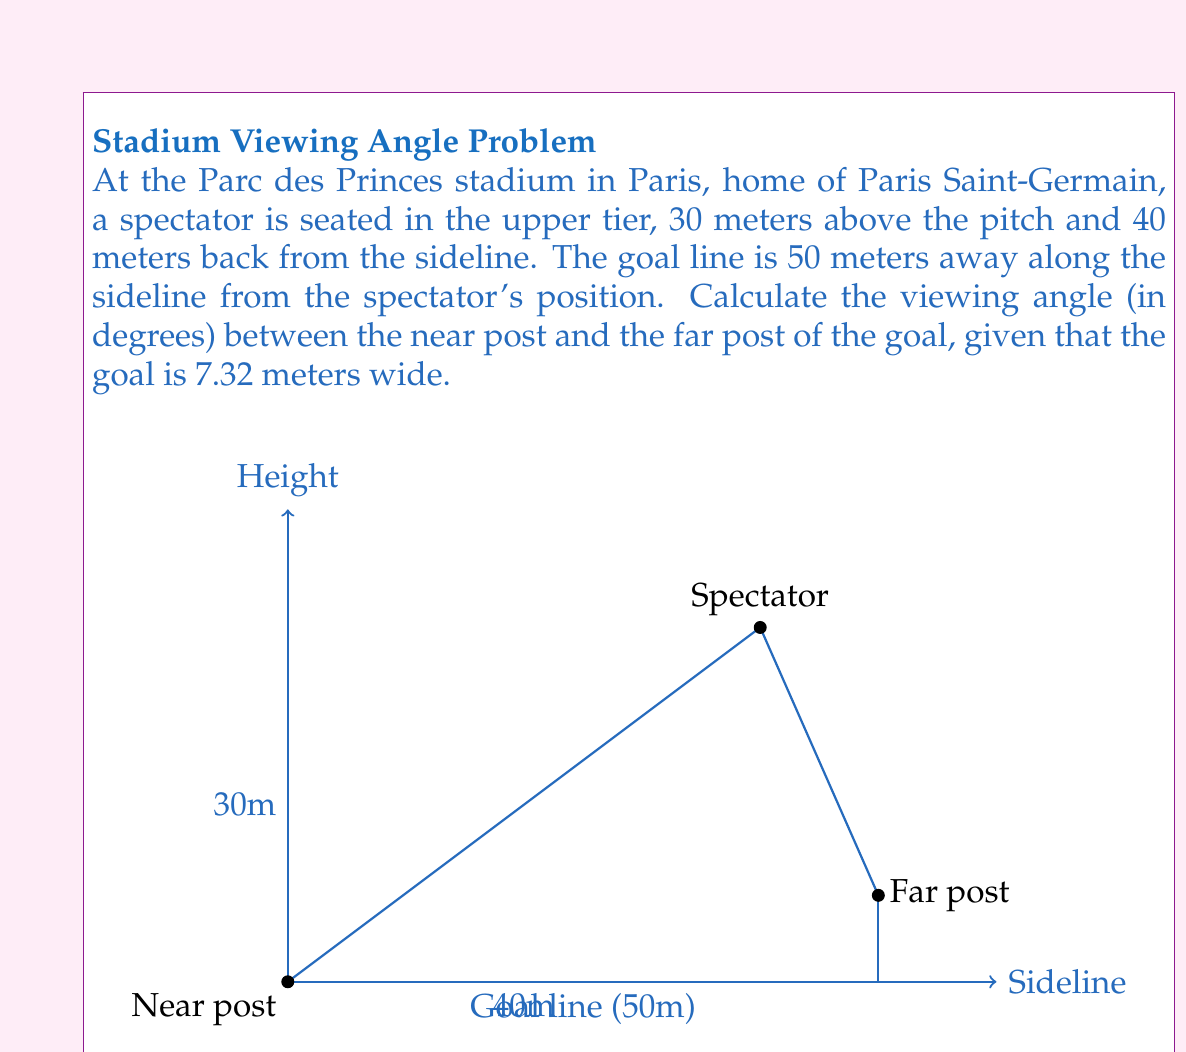Teach me how to tackle this problem. Let's approach this step-by-step:

1) We can use the arctangent function to calculate the angles. We need to find the angle between the lines from the spectator to each goal post.

2) For the near post:
   $\theta_1 = \arctan(\frac{30}{40}) = \arctan(0.75)$

3) For the far post, we need to calculate the distance from the spectator to the far post in both horizontal and vertical directions:
   Horizontal distance: $\sqrt{40^2 + 50^2} = \sqrt{4100} \approx 64.03$ meters
   Vertical distance: $30$ meters
   Far post height: $7.32$ meters
   
   $\theta_2 = \arctan(\frac{30 + 7.32}{64.03}) = \arctan(0.5829)$

4) The viewing angle is the difference between these two angles:
   $\text{Viewing angle} = \theta_2 - \theta_1$

5) Calculate:
   $\theta_1 = \arctan(0.75) \approx 36.87°$
   $\theta_2 = \arctan(0.5829) \approx 30.24°$

6) Therefore:
   $\text{Viewing angle} = 36.87° - 30.24° = 6.63°$
Answer: $6.63°$ 